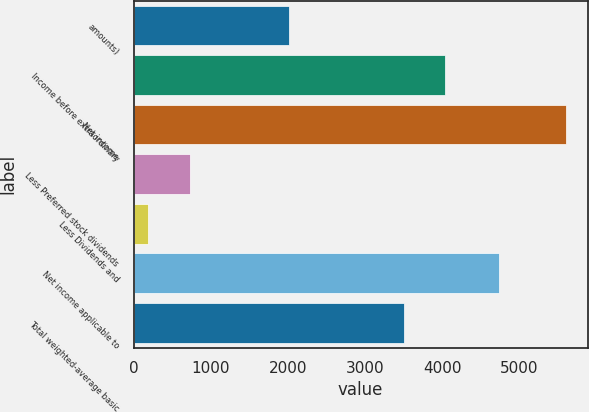Convert chart to OTSL. <chart><loc_0><loc_0><loc_500><loc_500><bar_chart><fcel>amounts)<fcel>Income before extraordinary<fcel>Net income<fcel>Less Preferred stock dividends<fcel>Less Dividends and<fcel>Net income applicable to<fcel>Total weighted-average basic<nl><fcel>2008<fcel>4042.7<fcel>5605<fcel>730.6<fcel>189<fcel>4742<fcel>3501.1<nl></chart> 